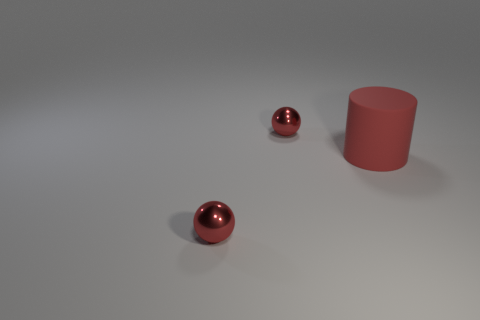How many shiny spheres are behind the small red thing left of the metallic sphere behind the big matte thing? 1 